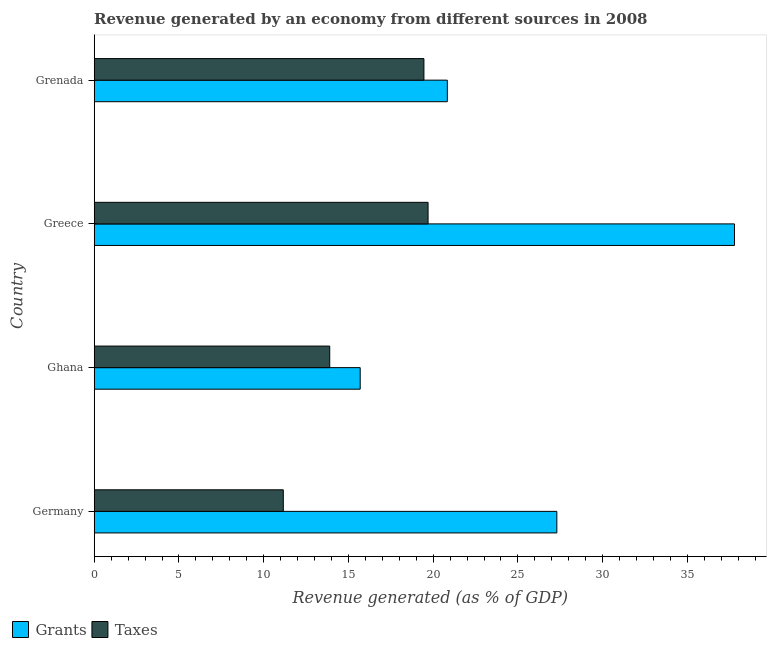Are the number of bars per tick equal to the number of legend labels?
Your response must be concise. Yes. In how many cases, is the number of bars for a given country not equal to the number of legend labels?
Provide a short and direct response. 0. What is the revenue generated by taxes in Greece?
Offer a very short reply. 19.7. Across all countries, what is the maximum revenue generated by taxes?
Keep it short and to the point. 19.7. Across all countries, what is the minimum revenue generated by grants?
Provide a short and direct response. 15.69. In which country was the revenue generated by grants minimum?
Make the answer very short. Ghana. What is the total revenue generated by grants in the graph?
Give a very brief answer. 101.6. What is the difference between the revenue generated by taxes in Germany and that in Grenada?
Offer a terse response. -8.3. What is the difference between the revenue generated by grants in Grenada and the revenue generated by taxes in Ghana?
Give a very brief answer. 6.94. What is the average revenue generated by grants per country?
Keep it short and to the point. 25.4. What is the difference between the revenue generated by taxes and revenue generated by grants in Greece?
Give a very brief answer. -18.08. What is the ratio of the revenue generated by grants in Ghana to that in Grenada?
Offer a very short reply. 0.75. Is the revenue generated by grants in Germany less than that in Greece?
Offer a very short reply. Yes. What is the difference between the highest and the second highest revenue generated by grants?
Provide a succinct answer. 10.48. What is the difference between the highest and the lowest revenue generated by taxes?
Keep it short and to the point. 8.54. Is the sum of the revenue generated by taxes in Germany and Ghana greater than the maximum revenue generated by grants across all countries?
Offer a very short reply. No. What does the 2nd bar from the top in Ghana represents?
Ensure brevity in your answer.  Grants. What does the 1st bar from the bottom in Germany represents?
Ensure brevity in your answer.  Grants. How many bars are there?
Offer a very short reply. 8. What is the difference between two consecutive major ticks on the X-axis?
Make the answer very short. 5. Does the graph contain any zero values?
Provide a short and direct response. No. Does the graph contain grids?
Give a very brief answer. No. Where does the legend appear in the graph?
Offer a terse response. Bottom left. How many legend labels are there?
Make the answer very short. 2. What is the title of the graph?
Your answer should be compact. Revenue generated by an economy from different sources in 2008. What is the label or title of the X-axis?
Give a very brief answer. Revenue generated (as % of GDP). What is the Revenue generated (as % of GDP) of Grants in Germany?
Your answer should be compact. 27.3. What is the Revenue generated (as % of GDP) of Taxes in Germany?
Offer a very short reply. 11.16. What is the Revenue generated (as % of GDP) in Grants in Ghana?
Give a very brief answer. 15.69. What is the Revenue generated (as % of GDP) in Taxes in Ghana?
Your response must be concise. 13.9. What is the Revenue generated (as % of GDP) in Grants in Greece?
Provide a short and direct response. 37.78. What is the Revenue generated (as % of GDP) in Taxes in Greece?
Your answer should be very brief. 19.7. What is the Revenue generated (as % of GDP) of Grants in Grenada?
Your answer should be compact. 20.83. What is the Revenue generated (as % of GDP) in Taxes in Grenada?
Offer a terse response. 19.45. Across all countries, what is the maximum Revenue generated (as % of GDP) of Grants?
Offer a terse response. 37.78. Across all countries, what is the maximum Revenue generated (as % of GDP) of Taxes?
Offer a very short reply. 19.7. Across all countries, what is the minimum Revenue generated (as % of GDP) of Grants?
Make the answer very short. 15.69. Across all countries, what is the minimum Revenue generated (as % of GDP) in Taxes?
Make the answer very short. 11.16. What is the total Revenue generated (as % of GDP) of Grants in the graph?
Your response must be concise. 101.6. What is the total Revenue generated (as % of GDP) in Taxes in the graph?
Your answer should be compact. 64.2. What is the difference between the Revenue generated (as % of GDP) of Grants in Germany and that in Ghana?
Give a very brief answer. 11.6. What is the difference between the Revenue generated (as % of GDP) of Taxes in Germany and that in Ghana?
Offer a terse response. -2.74. What is the difference between the Revenue generated (as % of GDP) of Grants in Germany and that in Greece?
Ensure brevity in your answer.  -10.48. What is the difference between the Revenue generated (as % of GDP) in Taxes in Germany and that in Greece?
Offer a terse response. -8.54. What is the difference between the Revenue generated (as % of GDP) in Grants in Germany and that in Grenada?
Offer a very short reply. 6.46. What is the difference between the Revenue generated (as % of GDP) in Taxes in Germany and that in Grenada?
Give a very brief answer. -8.3. What is the difference between the Revenue generated (as % of GDP) in Grants in Ghana and that in Greece?
Your response must be concise. -22.08. What is the difference between the Revenue generated (as % of GDP) in Taxes in Ghana and that in Greece?
Ensure brevity in your answer.  -5.8. What is the difference between the Revenue generated (as % of GDP) in Grants in Ghana and that in Grenada?
Offer a terse response. -5.14. What is the difference between the Revenue generated (as % of GDP) in Taxes in Ghana and that in Grenada?
Your response must be concise. -5.56. What is the difference between the Revenue generated (as % of GDP) in Grants in Greece and that in Grenada?
Your response must be concise. 16.94. What is the difference between the Revenue generated (as % of GDP) of Taxes in Greece and that in Grenada?
Give a very brief answer. 0.24. What is the difference between the Revenue generated (as % of GDP) in Grants in Germany and the Revenue generated (as % of GDP) in Taxes in Ghana?
Make the answer very short. 13.4. What is the difference between the Revenue generated (as % of GDP) in Grants in Germany and the Revenue generated (as % of GDP) in Taxes in Greece?
Keep it short and to the point. 7.6. What is the difference between the Revenue generated (as % of GDP) in Grants in Germany and the Revenue generated (as % of GDP) in Taxes in Grenada?
Your response must be concise. 7.84. What is the difference between the Revenue generated (as % of GDP) in Grants in Ghana and the Revenue generated (as % of GDP) in Taxes in Greece?
Offer a very short reply. -4. What is the difference between the Revenue generated (as % of GDP) of Grants in Ghana and the Revenue generated (as % of GDP) of Taxes in Grenada?
Give a very brief answer. -3.76. What is the difference between the Revenue generated (as % of GDP) of Grants in Greece and the Revenue generated (as % of GDP) of Taxes in Grenada?
Offer a very short reply. 18.32. What is the average Revenue generated (as % of GDP) in Grants per country?
Your answer should be compact. 25.4. What is the average Revenue generated (as % of GDP) in Taxes per country?
Provide a succinct answer. 16.05. What is the difference between the Revenue generated (as % of GDP) of Grants and Revenue generated (as % of GDP) of Taxes in Germany?
Your response must be concise. 16.14. What is the difference between the Revenue generated (as % of GDP) of Grants and Revenue generated (as % of GDP) of Taxes in Ghana?
Your response must be concise. 1.8. What is the difference between the Revenue generated (as % of GDP) in Grants and Revenue generated (as % of GDP) in Taxes in Greece?
Keep it short and to the point. 18.08. What is the difference between the Revenue generated (as % of GDP) of Grants and Revenue generated (as % of GDP) of Taxes in Grenada?
Provide a succinct answer. 1.38. What is the ratio of the Revenue generated (as % of GDP) in Grants in Germany to that in Ghana?
Offer a very short reply. 1.74. What is the ratio of the Revenue generated (as % of GDP) of Taxes in Germany to that in Ghana?
Your answer should be very brief. 0.8. What is the ratio of the Revenue generated (as % of GDP) in Grants in Germany to that in Greece?
Give a very brief answer. 0.72. What is the ratio of the Revenue generated (as % of GDP) in Taxes in Germany to that in Greece?
Give a very brief answer. 0.57. What is the ratio of the Revenue generated (as % of GDP) of Grants in Germany to that in Grenada?
Offer a very short reply. 1.31. What is the ratio of the Revenue generated (as % of GDP) in Taxes in Germany to that in Grenada?
Ensure brevity in your answer.  0.57. What is the ratio of the Revenue generated (as % of GDP) of Grants in Ghana to that in Greece?
Give a very brief answer. 0.42. What is the ratio of the Revenue generated (as % of GDP) of Taxes in Ghana to that in Greece?
Ensure brevity in your answer.  0.71. What is the ratio of the Revenue generated (as % of GDP) in Grants in Ghana to that in Grenada?
Keep it short and to the point. 0.75. What is the ratio of the Revenue generated (as % of GDP) of Taxes in Ghana to that in Grenada?
Keep it short and to the point. 0.71. What is the ratio of the Revenue generated (as % of GDP) of Grants in Greece to that in Grenada?
Give a very brief answer. 1.81. What is the ratio of the Revenue generated (as % of GDP) in Taxes in Greece to that in Grenada?
Offer a very short reply. 1.01. What is the difference between the highest and the second highest Revenue generated (as % of GDP) of Grants?
Your answer should be very brief. 10.48. What is the difference between the highest and the second highest Revenue generated (as % of GDP) of Taxes?
Provide a succinct answer. 0.24. What is the difference between the highest and the lowest Revenue generated (as % of GDP) of Grants?
Keep it short and to the point. 22.08. What is the difference between the highest and the lowest Revenue generated (as % of GDP) in Taxes?
Keep it short and to the point. 8.54. 